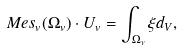<formula> <loc_0><loc_0><loc_500><loc_500>M e s _ { v } ( \Omega _ { v } ) \cdot U _ { v } = \int _ { \Omega _ { v } } \xi d _ { V } ,</formula> 